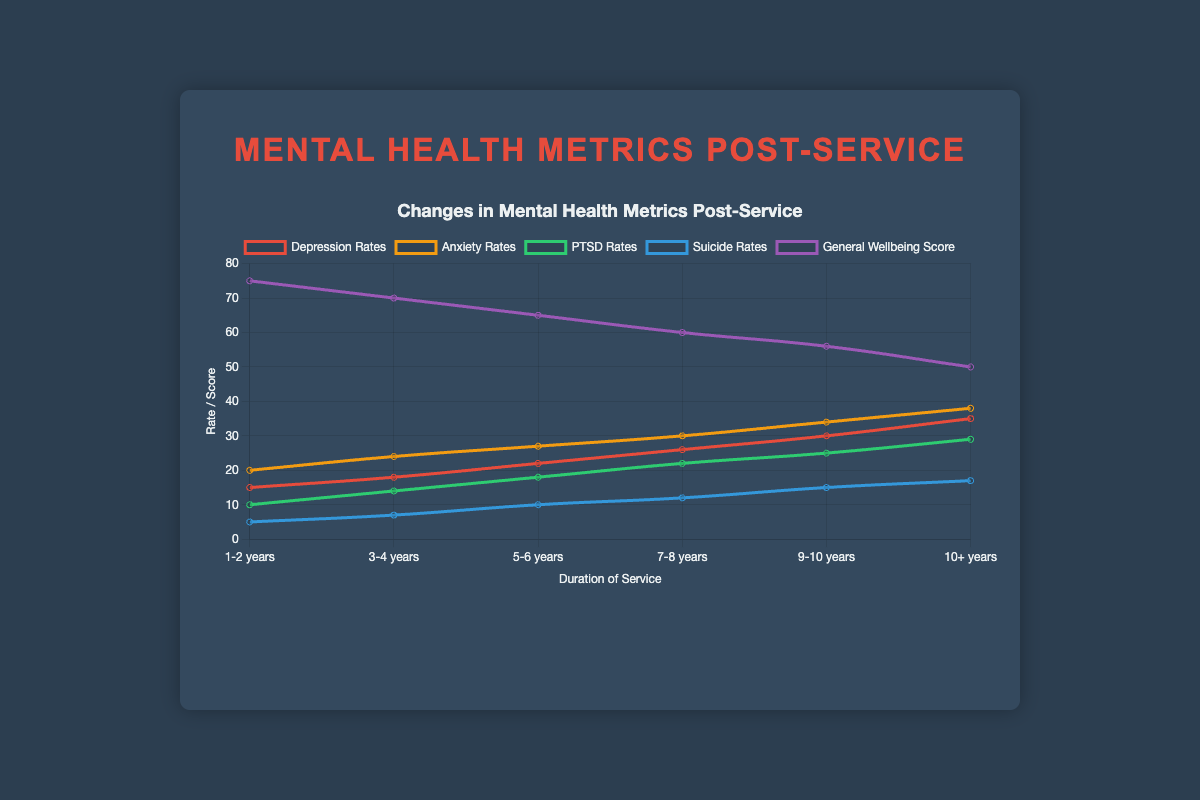What's the trend for Depression Rates over increasing duration of service? Observing the red line labeled 'Depression Rates', it shows a steady increase from 15 to 35 as the duration of service increases from 1-2 years to 10+ years.
Answer: Increasing Which mental health metric has the highest rate after 9-10 years of service? Looking at the values for 9-10 years of service, the Anxiety Rates (34) are higher than Depression Rates (30), PTSD Rates (25), and Suicide Rates (15).
Answer: Anxiety Rates Compare the trend lines for Anxiety Rates and Depression Rates over time. Which one increases more steeply? By visually comparing the slopes of the orange line (Anxiety Rates) and the red line (Depression Rates), the orange line has a steeper slope from 20 to 38 compared to the red line from 15 to 35.
Answer: Anxiety Rates What is the difference between the PTSD Rates and Suicide Rates at 7-8 years of service? At 7-8 years, PTSD Rates are 22 and Suicide Rates are 12. The difference is calculated as 22 - 12.
Answer: 10 Which mental health metric shows the most dramatic decrease in the plotted period? The purple line representing General Wellbeing Score shows a decrease from 75 to 50, indicating a 25-point drop, which is the most significant decrease compared to other metrics.
Answer: General Wellbeing Score If you average the Depression Rates and Anxiety Rates for the 5-6 years duration, what value do you get? For 5-6 years, Depression Rates are 22 and Anxiety Rates are 27. Averaging these gives (22 + 27) / 2.
Answer: 24.5 How does the General Wellbeing Score compare visually to the other mental health metrics over the duration of service? The General Wellbeing Score, represented by the purple line, visually trends downwards while other metrics represented by red, orange, green, and blue lines trend upwards over time.
Answer: Downward trend Which duration of service experiences the sharpest increase in Depression Rates compared to the previous year? The sharpest increase in Depression Rates is between 9-10 years (30) and 10+ years (35), calculated as 35 - 30 = 5.
Answer: 9-10 to 10+ years At 10+ years of service, how do the PTSD Rates compare to Anxiety Rates? At 10+ years, PTSD Rates are 29 and Anxiety Rates are 38. PTSD Rates are 9 points lower.
Answer: 9 points lower 